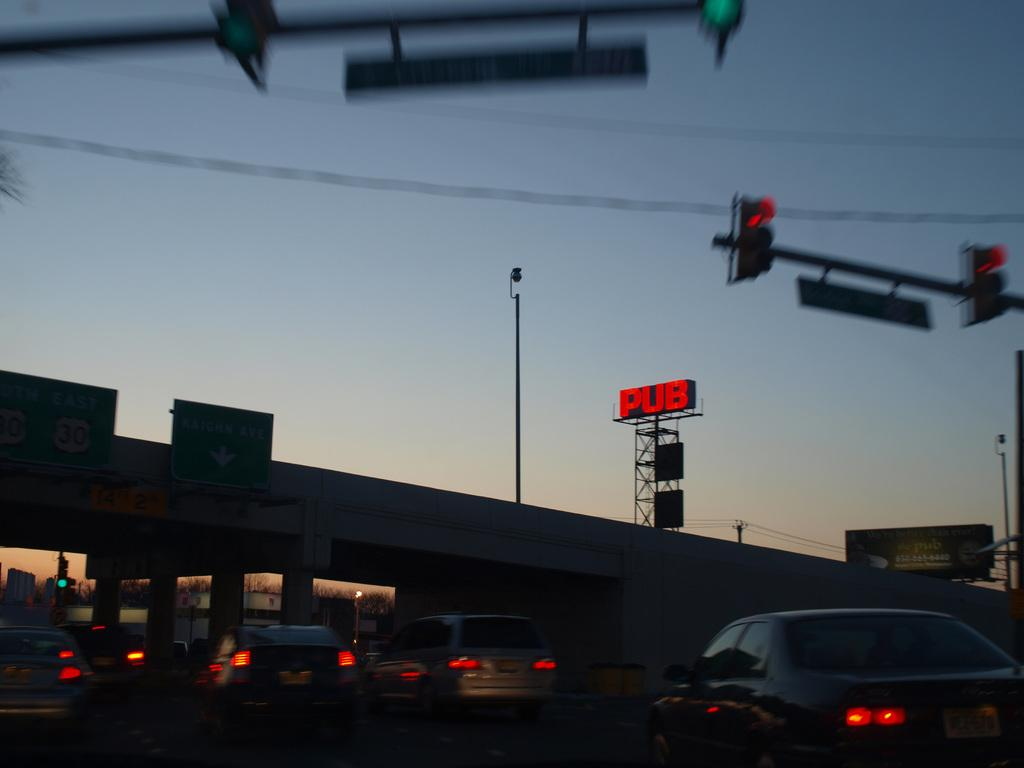<image>
Present a compact description of the photo's key features. A city street scene with a neon sign that says pub over it. 